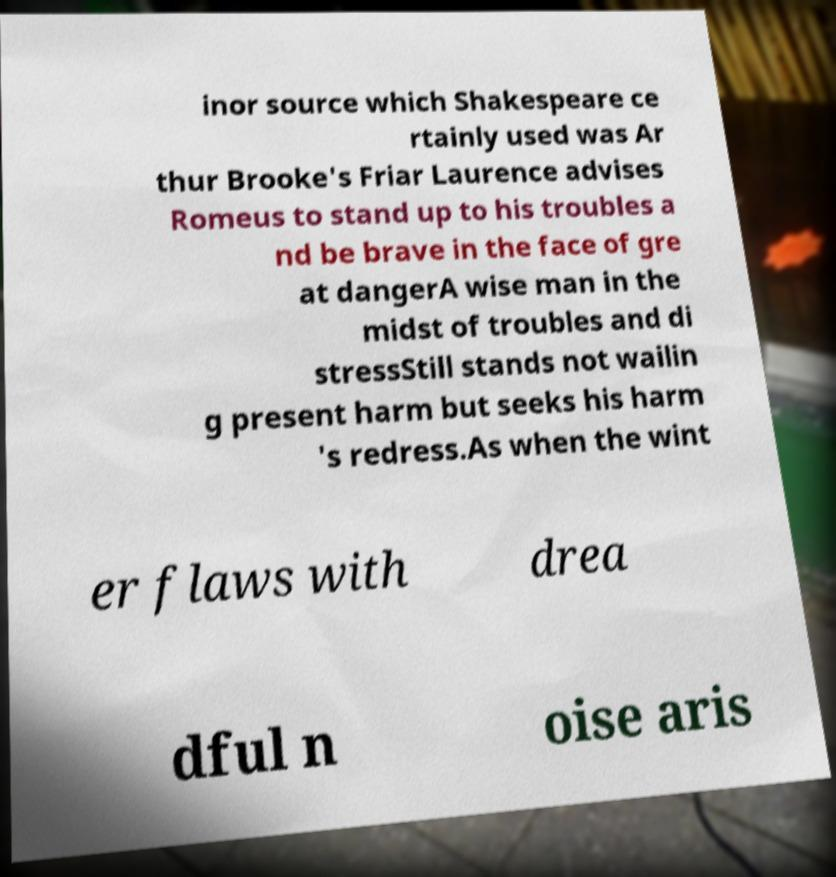For documentation purposes, I need the text within this image transcribed. Could you provide that? inor source which Shakespeare ce rtainly used was Ar thur Brooke's Friar Laurence advises Romeus to stand up to his troubles a nd be brave in the face of gre at dangerA wise man in the midst of troubles and di stressStill stands not wailin g present harm but seeks his harm 's redress.As when the wint er flaws with drea dful n oise aris 